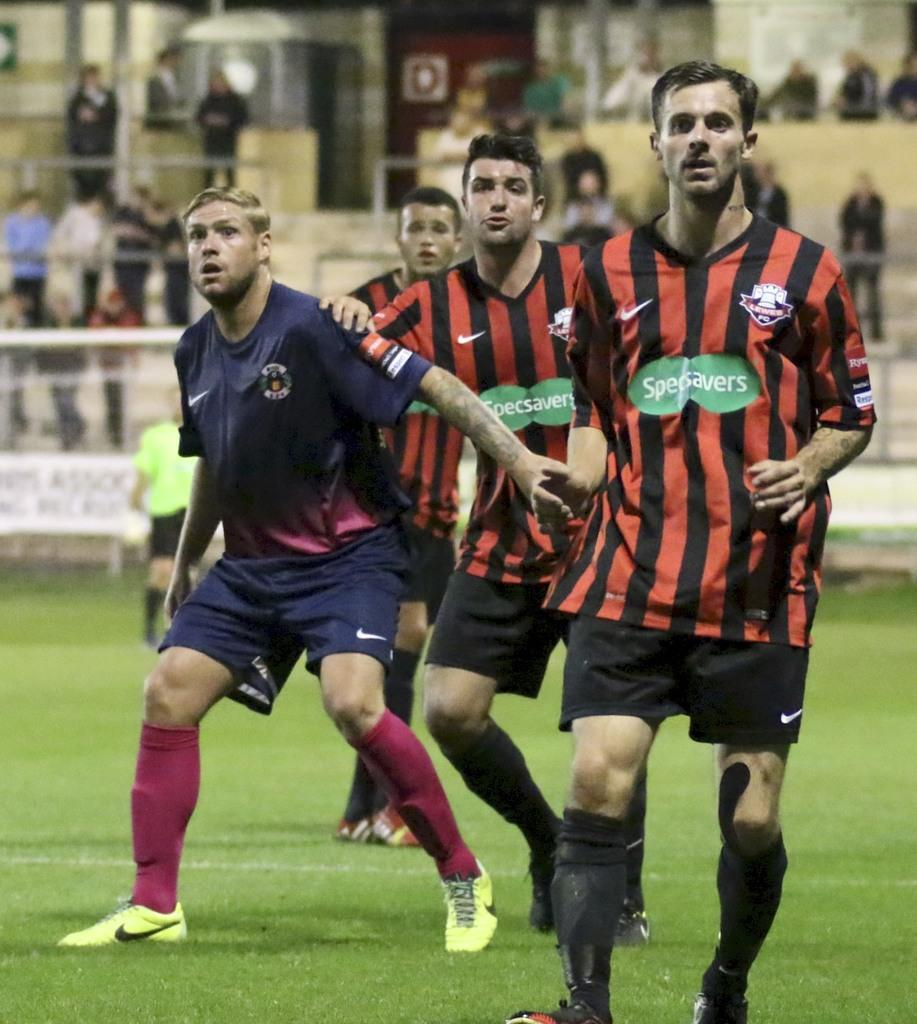What activity are the people in the image engaged in? The people in the image are playing a game. What can be seen in the background of the image? There is a crowd standing in the background of the image. What is the purpose of the fence visible in the image? The fence is likely there to separate the playing area from the surrounding space. What type of surface is at the bottom of the image? There is grass at the bottom of the image. How many mice can be seen running around in the image? There are no mice present in the image. What type of mailbox is visible in the image? There is no mailbox present in the image. 